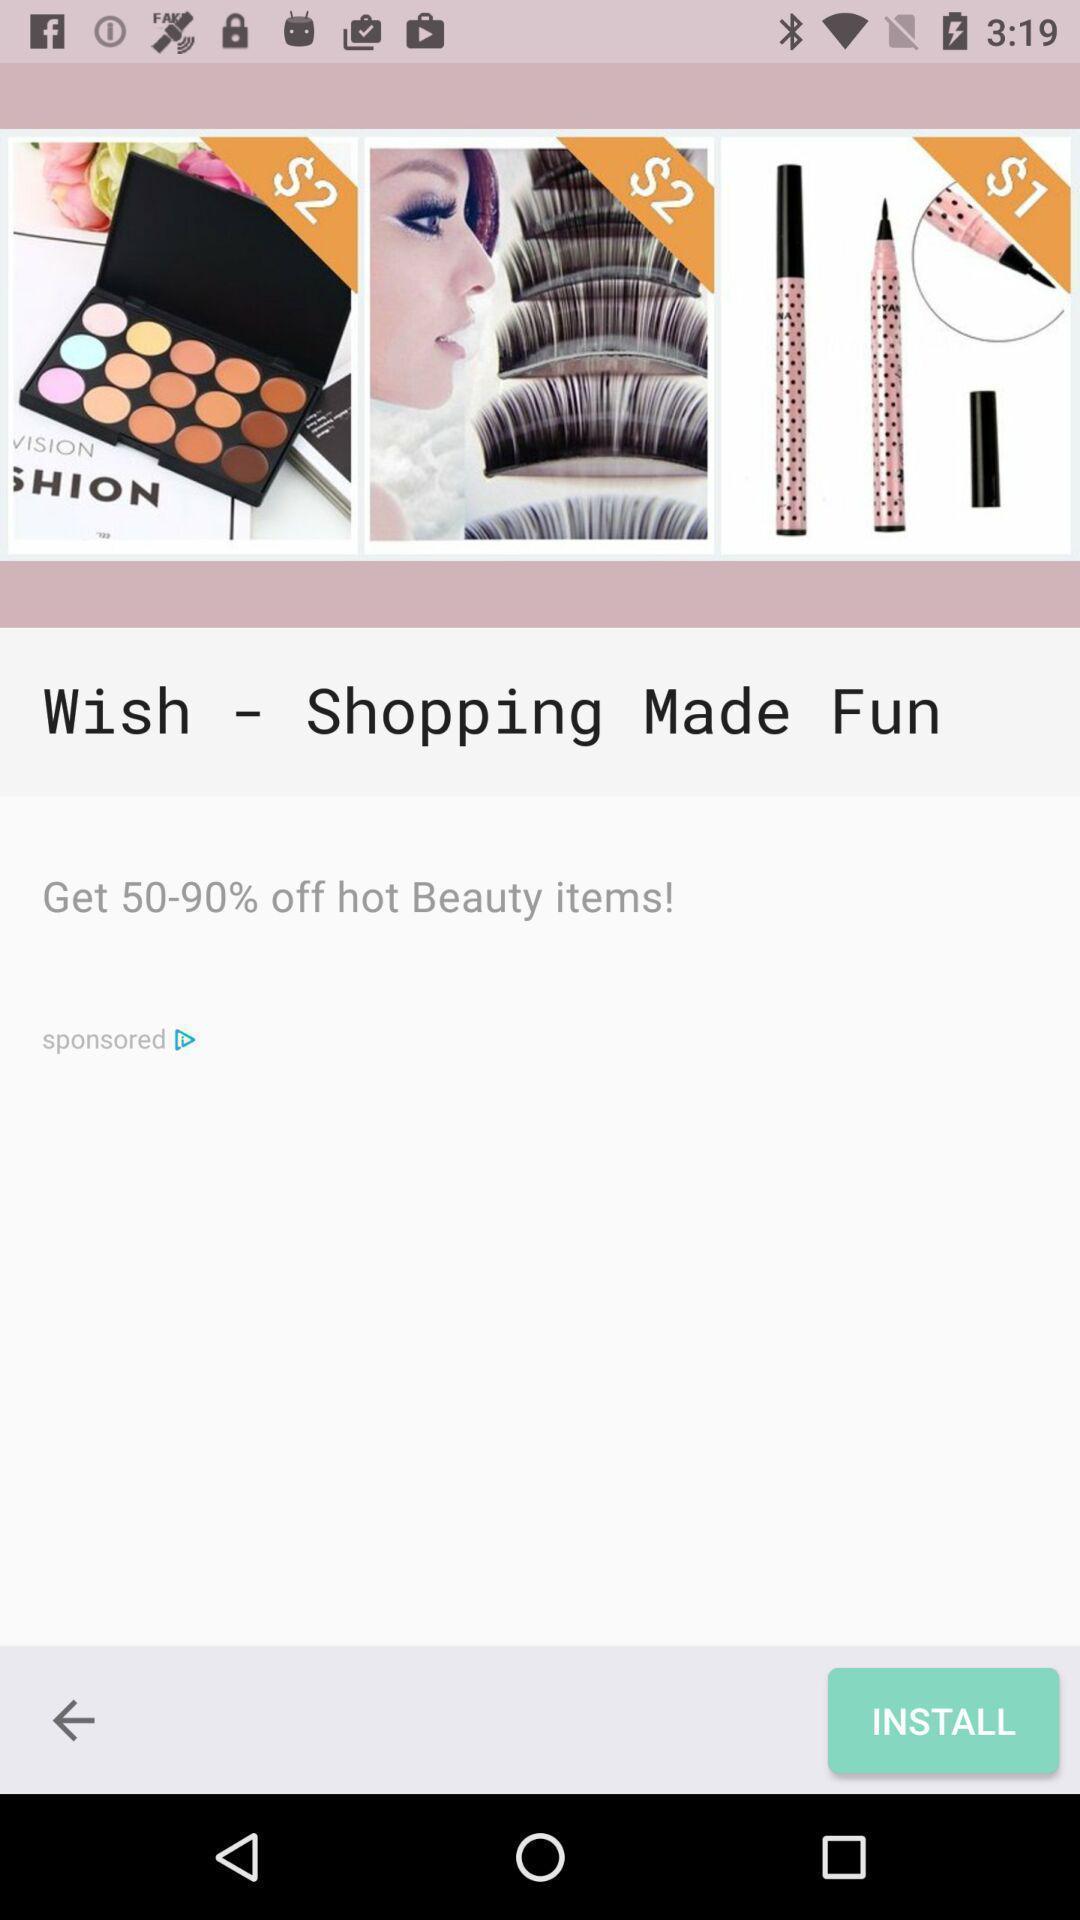What is the overall content of this screenshot? Screen page of shopping app. 